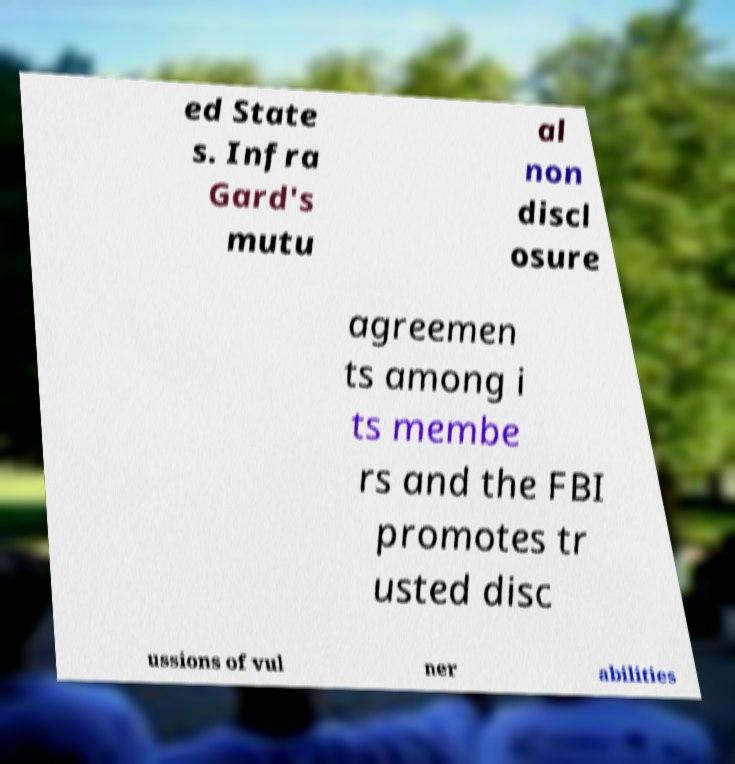I need the written content from this picture converted into text. Can you do that? ed State s. Infra Gard's mutu al non discl osure agreemen ts among i ts membe rs and the FBI promotes tr usted disc ussions of vul ner abilities 